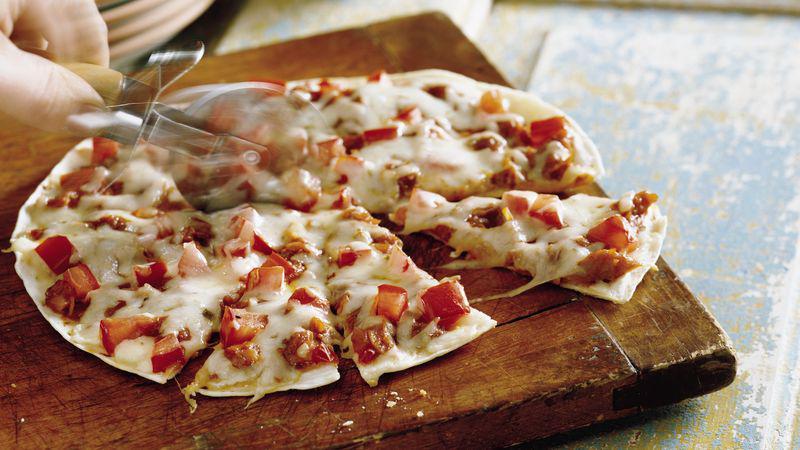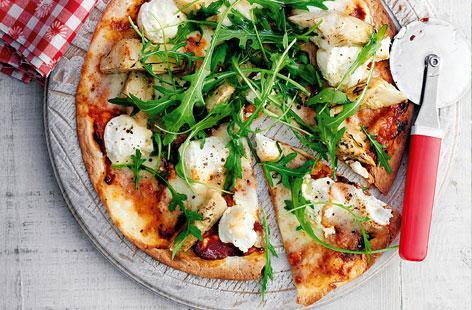The first image is the image on the left, the second image is the image on the right. For the images displayed, is the sentence "A single slice is pulled away from the otherwise whole pizza in the image on the left." factually correct? Answer yes or no. Yes. 